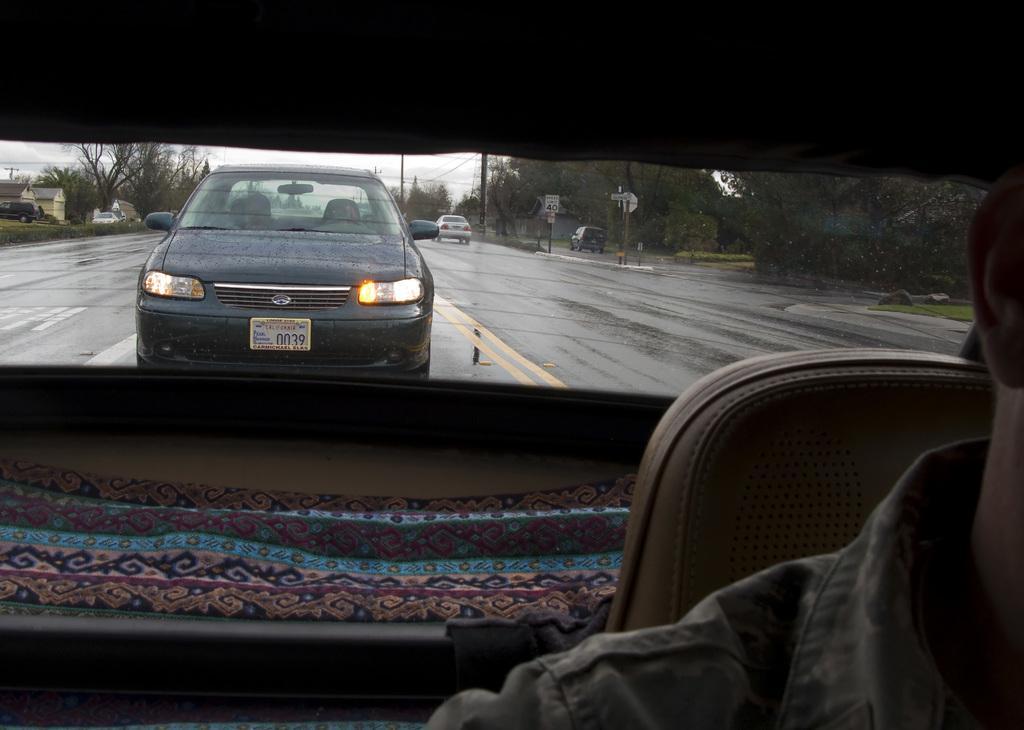Describe this image in one or two sentences. In this image there is a person sitting on the seat inside a vehicle, and at the background there are vehicles on the road, buildings, grass, boards attached to the poles, trees,sky. 